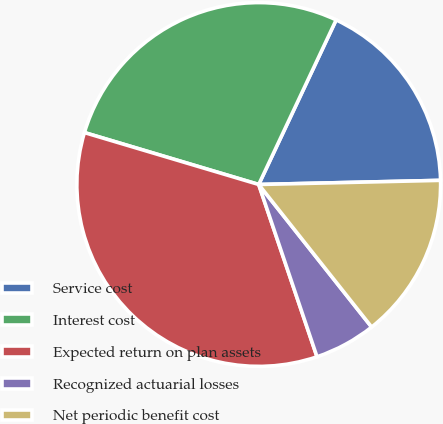<chart> <loc_0><loc_0><loc_500><loc_500><pie_chart><fcel>Service cost<fcel>Interest cost<fcel>Expected return on plan assets<fcel>Recognized actuarial losses<fcel>Net periodic benefit cost<nl><fcel>17.64%<fcel>27.39%<fcel>34.8%<fcel>5.47%<fcel>14.7%<nl></chart> 